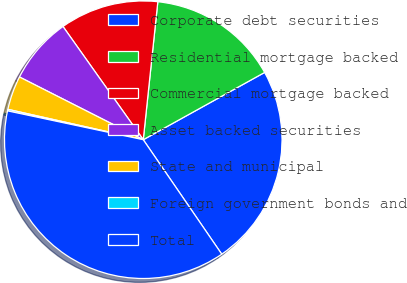Convert chart. <chart><loc_0><loc_0><loc_500><loc_500><pie_chart><fcel>Corporate debt securities<fcel>Residential mortgage backed<fcel>Commercial mortgage backed<fcel>Asset backed securities<fcel>State and municipal<fcel>Foreign government bonds and<fcel>Total<nl><fcel>23.49%<fcel>15.27%<fcel>11.49%<fcel>7.72%<fcel>3.95%<fcel>0.18%<fcel>37.9%<nl></chart> 